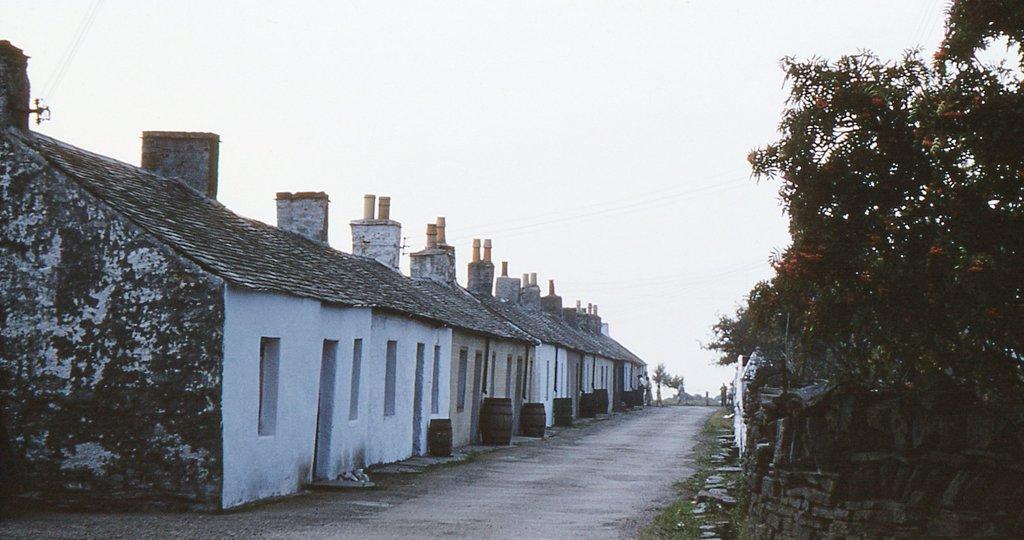How would you summarize this image in a sentence or two? This is the picture of a place where we have some houses and also we can see some containers, trees, plants and some other things. 